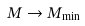Convert formula to latex. <formula><loc_0><loc_0><loc_500><loc_500>M \rightarrow M _ { \min }</formula> 